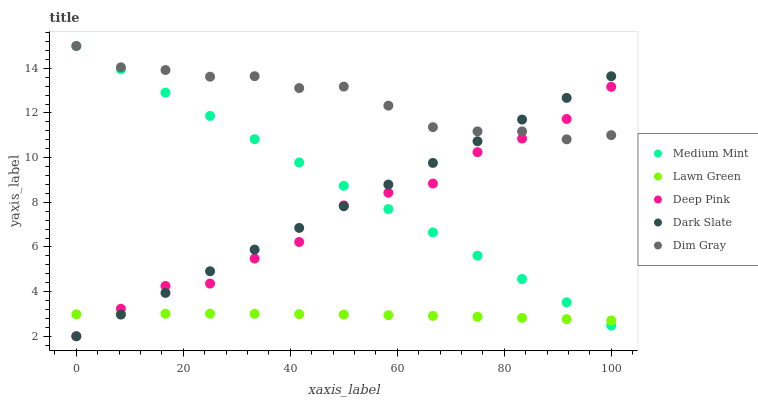Does Lawn Green have the minimum area under the curve?
Answer yes or no. Yes. Does Dim Gray have the maximum area under the curve?
Answer yes or no. Yes. Does Dim Gray have the minimum area under the curve?
Answer yes or no. No. Does Lawn Green have the maximum area under the curve?
Answer yes or no. No. Is Dark Slate the smoothest?
Answer yes or no. Yes. Is Deep Pink the roughest?
Answer yes or no. Yes. Is Lawn Green the smoothest?
Answer yes or no. No. Is Lawn Green the roughest?
Answer yes or no. No. Does Deep Pink have the lowest value?
Answer yes or no. Yes. Does Lawn Green have the lowest value?
Answer yes or no. No. Does Dim Gray have the highest value?
Answer yes or no. Yes. Does Lawn Green have the highest value?
Answer yes or no. No. Is Lawn Green less than Dim Gray?
Answer yes or no. Yes. Is Dim Gray greater than Lawn Green?
Answer yes or no. Yes. Does Deep Pink intersect Dim Gray?
Answer yes or no. Yes. Is Deep Pink less than Dim Gray?
Answer yes or no. No. Is Deep Pink greater than Dim Gray?
Answer yes or no. No. Does Lawn Green intersect Dim Gray?
Answer yes or no. No. 